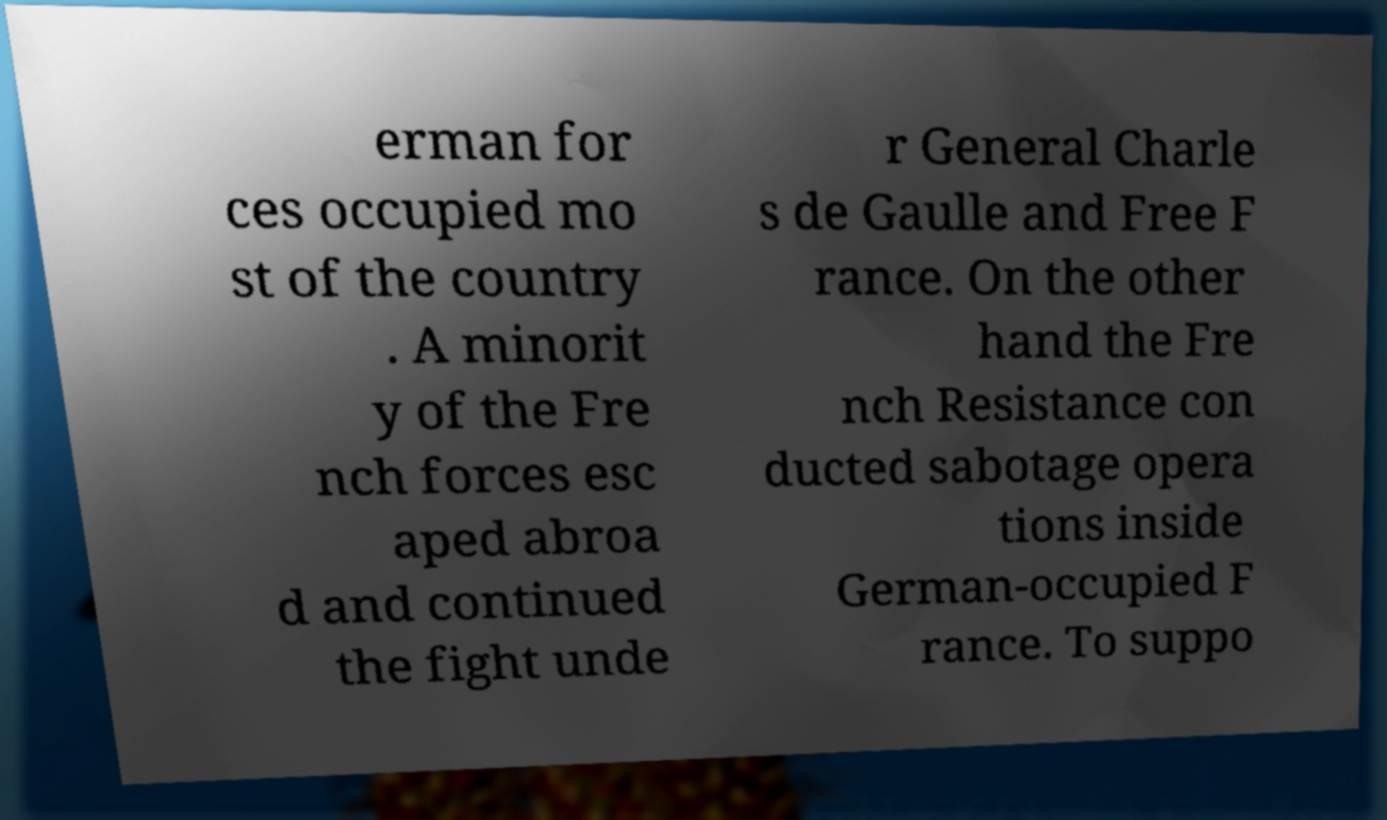Could you assist in decoding the text presented in this image and type it out clearly? erman for ces occupied mo st of the country . A minorit y of the Fre nch forces esc aped abroa d and continued the fight unde r General Charle s de Gaulle and Free F rance. On the other hand the Fre nch Resistance con ducted sabotage opera tions inside German-occupied F rance. To suppo 